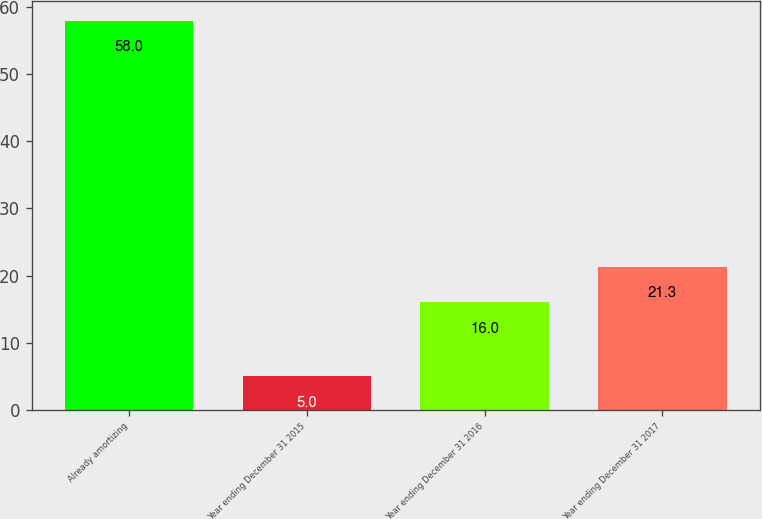Convert chart. <chart><loc_0><loc_0><loc_500><loc_500><bar_chart><fcel>Already amortizing<fcel>Year ending December 31 2015<fcel>Year ending December 31 2016<fcel>Year ending December 31 2017<nl><fcel>58<fcel>5<fcel>16<fcel>21.3<nl></chart> 